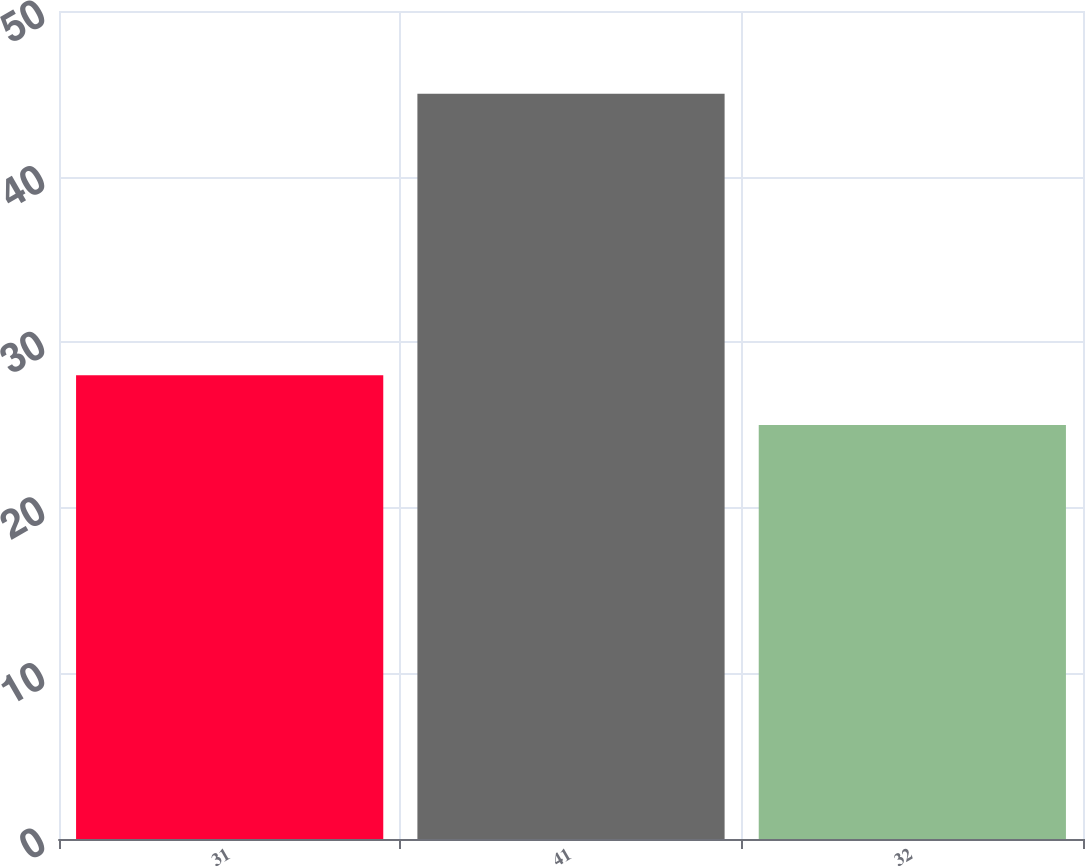Convert chart. <chart><loc_0><loc_0><loc_500><loc_500><bar_chart><fcel>31<fcel>41<fcel>32<nl><fcel>28<fcel>45<fcel>25<nl></chart> 